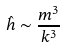<formula> <loc_0><loc_0><loc_500><loc_500>\hat { h } \sim \frac { m ^ { 3 } } { k ^ { 3 } }</formula> 